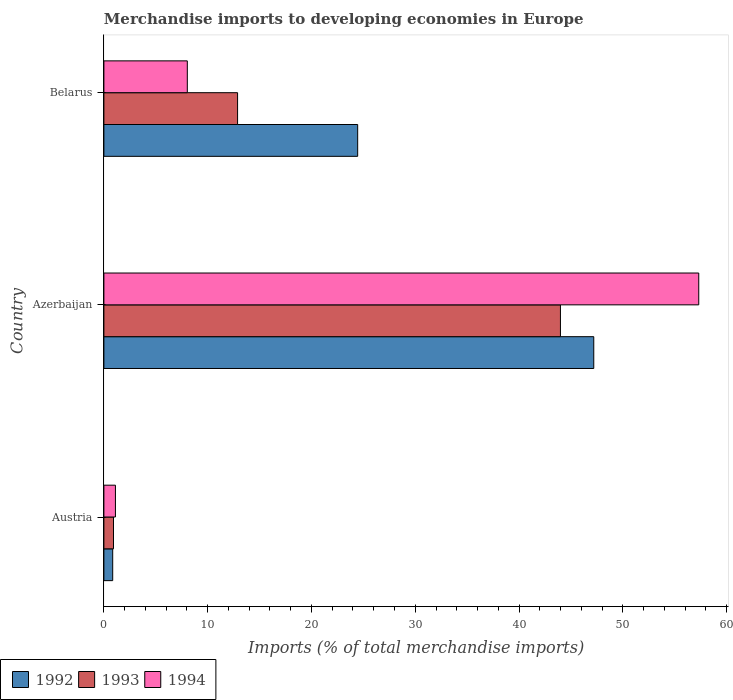How many different coloured bars are there?
Provide a short and direct response. 3. How many groups of bars are there?
Provide a succinct answer. 3. Are the number of bars on each tick of the Y-axis equal?
Your answer should be very brief. Yes. How many bars are there on the 1st tick from the bottom?
Your answer should be compact. 3. What is the label of the 2nd group of bars from the top?
Your answer should be compact. Azerbaijan. What is the percentage total merchandise imports in 1994 in Azerbaijan?
Ensure brevity in your answer.  57.31. Across all countries, what is the maximum percentage total merchandise imports in 1993?
Your answer should be compact. 43.99. Across all countries, what is the minimum percentage total merchandise imports in 1992?
Give a very brief answer. 0.85. In which country was the percentage total merchandise imports in 1992 maximum?
Provide a succinct answer. Azerbaijan. In which country was the percentage total merchandise imports in 1993 minimum?
Your answer should be compact. Austria. What is the total percentage total merchandise imports in 1994 in the graph?
Make the answer very short. 66.46. What is the difference between the percentage total merchandise imports in 1992 in Austria and that in Belarus?
Your answer should be compact. -23.6. What is the difference between the percentage total merchandise imports in 1992 in Belarus and the percentage total merchandise imports in 1994 in Azerbaijan?
Give a very brief answer. -32.86. What is the average percentage total merchandise imports in 1994 per country?
Provide a short and direct response. 22.15. What is the difference between the percentage total merchandise imports in 1994 and percentage total merchandise imports in 1992 in Belarus?
Give a very brief answer. -16.41. In how many countries, is the percentage total merchandise imports in 1992 greater than 18 %?
Offer a very short reply. 2. What is the ratio of the percentage total merchandise imports in 1993 in Azerbaijan to that in Belarus?
Your answer should be very brief. 3.42. Is the difference between the percentage total merchandise imports in 1994 in Azerbaijan and Belarus greater than the difference between the percentage total merchandise imports in 1992 in Azerbaijan and Belarus?
Your answer should be very brief. Yes. What is the difference between the highest and the second highest percentage total merchandise imports in 1993?
Offer a terse response. 31.11. What is the difference between the highest and the lowest percentage total merchandise imports in 1992?
Ensure brevity in your answer.  46.35. Is it the case that in every country, the sum of the percentage total merchandise imports in 1993 and percentage total merchandise imports in 1992 is greater than the percentage total merchandise imports in 1994?
Make the answer very short. Yes. How many bars are there?
Make the answer very short. 9. What is the title of the graph?
Keep it short and to the point. Merchandise imports to developing economies in Europe. What is the label or title of the X-axis?
Your response must be concise. Imports (% of total merchandise imports). What is the label or title of the Y-axis?
Offer a very short reply. Country. What is the Imports (% of total merchandise imports) in 1992 in Austria?
Ensure brevity in your answer.  0.85. What is the Imports (% of total merchandise imports) in 1993 in Austria?
Keep it short and to the point. 0.93. What is the Imports (% of total merchandise imports) of 1994 in Austria?
Your response must be concise. 1.11. What is the Imports (% of total merchandise imports) of 1992 in Azerbaijan?
Your answer should be compact. 47.2. What is the Imports (% of total merchandise imports) of 1993 in Azerbaijan?
Your answer should be compact. 43.99. What is the Imports (% of total merchandise imports) of 1994 in Azerbaijan?
Give a very brief answer. 57.31. What is the Imports (% of total merchandise imports) of 1992 in Belarus?
Your response must be concise. 24.45. What is the Imports (% of total merchandise imports) of 1993 in Belarus?
Give a very brief answer. 12.88. What is the Imports (% of total merchandise imports) in 1994 in Belarus?
Provide a succinct answer. 8.04. Across all countries, what is the maximum Imports (% of total merchandise imports) of 1992?
Give a very brief answer. 47.2. Across all countries, what is the maximum Imports (% of total merchandise imports) of 1993?
Offer a very short reply. 43.99. Across all countries, what is the maximum Imports (% of total merchandise imports) of 1994?
Keep it short and to the point. 57.31. Across all countries, what is the minimum Imports (% of total merchandise imports) in 1992?
Provide a short and direct response. 0.85. Across all countries, what is the minimum Imports (% of total merchandise imports) in 1993?
Offer a terse response. 0.93. Across all countries, what is the minimum Imports (% of total merchandise imports) in 1994?
Your answer should be compact. 1.11. What is the total Imports (% of total merchandise imports) of 1992 in the graph?
Your response must be concise. 72.5. What is the total Imports (% of total merchandise imports) in 1993 in the graph?
Ensure brevity in your answer.  57.79. What is the total Imports (% of total merchandise imports) of 1994 in the graph?
Give a very brief answer. 66.46. What is the difference between the Imports (% of total merchandise imports) of 1992 in Austria and that in Azerbaijan?
Keep it short and to the point. -46.35. What is the difference between the Imports (% of total merchandise imports) in 1993 in Austria and that in Azerbaijan?
Offer a very short reply. -43.06. What is the difference between the Imports (% of total merchandise imports) in 1994 in Austria and that in Azerbaijan?
Your response must be concise. -56.2. What is the difference between the Imports (% of total merchandise imports) in 1992 in Austria and that in Belarus?
Provide a succinct answer. -23.6. What is the difference between the Imports (% of total merchandise imports) in 1993 in Austria and that in Belarus?
Make the answer very short. -11.95. What is the difference between the Imports (% of total merchandise imports) of 1994 in Austria and that in Belarus?
Provide a succinct answer. -6.92. What is the difference between the Imports (% of total merchandise imports) in 1992 in Azerbaijan and that in Belarus?
Offer a terse response. 22.75. What is the difference between the Imports (% of total merchandise imports) in 1993 in Azerbaijan and that in Belarus?
Offer a terse response. 31.11. What is the difference between the Imports (% of total merchandise imports) in 1994 in Azerbaijan and that in Belarus?
Your answer should be very brief. 49.28. What is the difference between the Imports (% of total merchandise imports) in 1992 in Austria and the Imports (% of total merchandise imports) in 1993 in Azerbaijan?
Provide a short and direct response. -43.14. What is the difference between the Imports (% of total merchandise imports) of 1992 in Austria and the Imports (% of total merchandise imports) of 1994 in Azerbaijan?
Your answer should be compact. -56.46. What is the difference between the Imports (% of total merchandise imports) in 1993 in Austria and the Imports (% of total merchandise imports) in 1994 in Azerbaijan?
Offer a terse response. -56.39. What is the difference between the Imports (% of total merchandise imports) in 1992 in Austria and the Imports (% of total merchandise imports) in 1993 in Belarus?
Keep it short and to the point. -12.03. What is the difference between the Imports (% of total merchandise imports) of 1992 in Austria and the Imports (% of total merchandise imports) of 1994 in Belarus?
Make the answer very short. -7.19. What is the difference between the Imports (% of total merchandise imports) of 1993 in Austria and the Imports (% of total merchandise imports) of 1994 in Belarus?
Your response must be concise. -7.11. What is the difference between the Imports (% of total merchandise imports) in 1992 in Azerbaijan and the Imports (% of total merchandise imports) in 1993 in Belarus?
Your answer should be very brief. 34.32. What is the difference between the Imports (% of total merchandise imports) in 1992 in Azerbaijan and the Imports (% of total merchandise imports) in 1994 in Belarus?
Offer a very short reply. 39.16. What is the difference between the Imports (% of total merchandise imports) of 1993 in Azerbaijan and the Imports (% of total merchandise imports) of 1994 in Belarus?
Your answer should be very brief. 35.95. What is the average Imports (% of total merchandise imports) of 1992 per country?
Ensure brevity in your answer.  24.17. What is the average Imports (% of total merchandise imports) in 1993 per country?
Your answer should be compact. 19.26. What is the average Imports (% of total merchandise imports) of 1994 per country?
Offer a terse response. 22.15. What is the difference between the Imports (% of total merchandise imports) of 1992 and Imports (% of total merchandise imports) of 1993 in Austria?
Keep it short and to the point. -0.08. What is the difference between the Imports (% of total merchandise imports) of 1992 and Imports (% of total merchandise imports) of 1994 in Austria?
Your response must be concise. -0.26. What is the difference between the Imports (% of total merchandise imports) of 1993 and Imports (% of total merchandise imports) of 1994 in Austria?
Your answer should be very brief. -0.19. What is the difference between the Imports (% of total merchandise imports) of 1992 and Imports (% of total merchandise imports) of 1993 in Azerbaijan?
Your answer should be very brief. 3.21. What is the difference between the Imports (% of total merchandise imports) of 1992 and Imports (% of total merchandise imports) of 1994 in Azerbaijan?
Your response must be concise. -10.11. What is the difference between the Imports (% of total merchandise imports) in 1993 and Imports (% of total merchandise imports) in 1994 in Azerbaijan?
Provide a succinct answer. -13.33. What is the difference between the Imports (% of total merchandise imports) in 1992 and Imports (% of total merchandise imports) in 1993 in Belarus?
Your answer should be compact. 11.57. What is the difference between the Imports (% of total merchandise imports) of 1992 and Imports (% of total merchandise imports) of 1994 in Belarus?
Your answer should be compact. 16.41. What is the difference between the Imports (% of total merchandise imports) of 1993 and Imports (% of total merchandise imports) of 1994 in Belarus?
Your answer should be very brief. 4.84. What is the ratio of the Imports (% of total merchandise imports) in 1992 in Austria to that in Azerbaijan?
Provide a short and direct response. 0.02. What is the ratio of the Imports (% of total merchandise imports) in 1993 in Austria to that in Azerbaijan?
Offer a terse response. 0.02. What is the ratio of the Imports (% of total merchandise imports) in 1994 in Austria to that in Azerbaijan?
Provide a succinct answer. 0.02. What is the ratio of the Imports (% of total merchandise imports) of 1992 in Austria to that in Belarus?
Ensure brevity in your answer.  0.03. What is the ratio of the Imports (% of total merchandise imports) of 1993 in Austria to that in Belarus?
Your response must be concise. 0.07. What is the ratio of the Imports (% of total merchandise imports) in 1994 in Austria to that in Belarus?
Your answer should be compact. 0.14. What is the ratio of the Imports (% of total merchandise imports) of 1992 in Azerbaijan to that in Belarus?
Provide a succinct answer. 1.93. What is the ratio of the Imports (% of total merchandise imports) of 1993 in Azerbaijan to that in Belarus?
Offer a very short reply. 3.42. What is the ratio of the Imports (% of total merchandise imports) in 1994 in Azerbaijan to that in Belarus?
Your response must be concise. 7.13. What is the difference between the highest and the second highest Imports (% of total merchandise imports) of 1992?
Keep it short and to the point. 22.75. What is the difference between the highest and the second highest Imports (% of total merchandise imports) in 1993?
Ensure brevity in your answer.  31.11. What is the difference between the highest and the second highest Imports (% of total merchandise imports) in 1994?
Offer a terse response. 49.28. What is the difference between the highest and the lowest Imports (% of total merchandise imports) of 1992?
Offer a terse response. 46.35. What is the difference between the highest and the lowest Imports (% of total merchandise imports) of 1993?
Keep it short and to the point. 43.06. What is the difference between the highest and the lowest Imports (% of total merchandise imports) in 1994?
Keep it short and to the point. 56.2. 